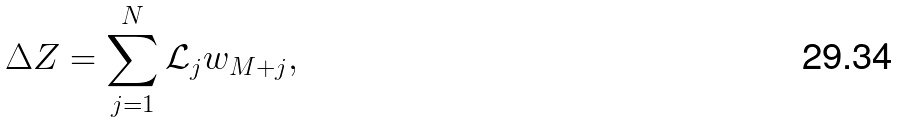<formula> <loc_0><loc_0><loc_500><loc_500>\Delta Z = \sum _ { j = 1 } ^ { N } \mathcal { L } _ { j } w _ { M + j } ,</formula> 